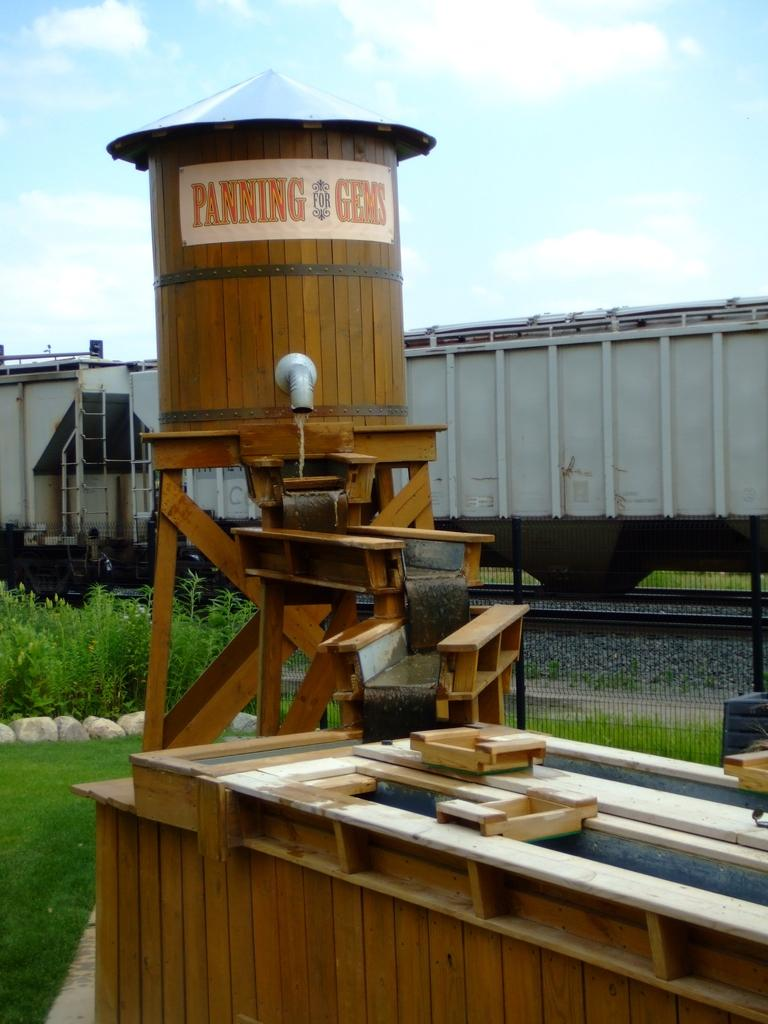What is the main subject of the image? The main subject of the image is a train on the track. What type of vegetation can be seen in the image? There is grass visible in the image. What other objects are present in the image? There is a water tanker and a pipe in the image. How would you describe the weather in the image? The sky is cloudy in the image, suggesting a potentially overcast or rainy day. How many dogs are playing with the coat in the image? There are no dogs or coats present in the image; it features a train on a track with grass, a water tanker, and a pipe. 